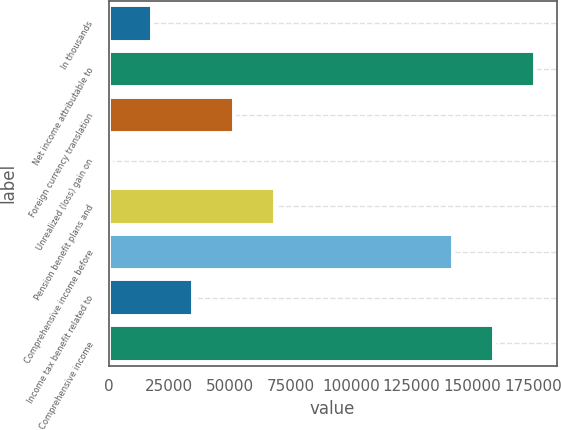Convert chart. <chart><loc_0><loc_0><loc_500><loc_500><bar_chart><fcel>In thousands<fcel>Net income attributable to<fcel>Foreign currency translation<fcel>Unrealized (loss) gain on<fcel>Pension benefit plans and<fcel>Comprehensive income before<fcel>Income tax benefit related to<fcel>Comprehensive income<nl><fcel>18001.3<fcel>176113<fcel>51811.9<fcel>1096<fcel>68717.2<fcel>142302<fcel>34906.6<fcel>159207<nl></chart> 